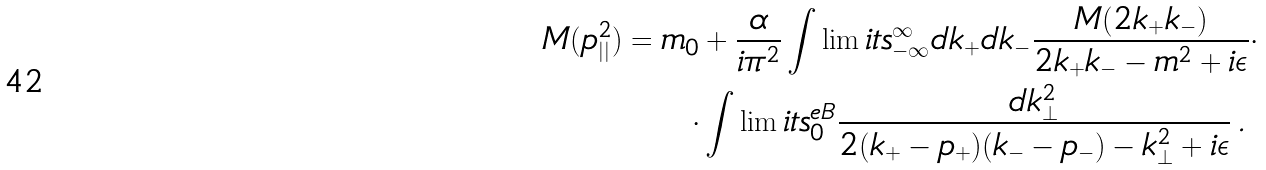Convert formula to latex. <formula><loc_0><loc_0><loc_500><loc_500>M ( p _ { | | } ^ { 2 } ) = m _ { 0 } & + \frac { \alpha } { i \pi ^ { 2 } } \int \lim i t s _ { - \infty } ^ { \infty } d k _ { + } d k _ { - } \frac { M ( 2 k _ { + } k _ { - } ) } { 2 k _ { + } k _ { - } - m ^ { 2 } + i \epsilon } \cdot \\ \cdot & \int \lim i t s _ { 0 } ^ { e B } \frac { d { k } _ { \perp } ^ { 2 } } { 2 ( k _ { + } - p _ { + } ) ( k _ { - } - p _ { - } ) - { k } _ { \perp } ^ { 2 } + i \epsilon } \, .</formula> 